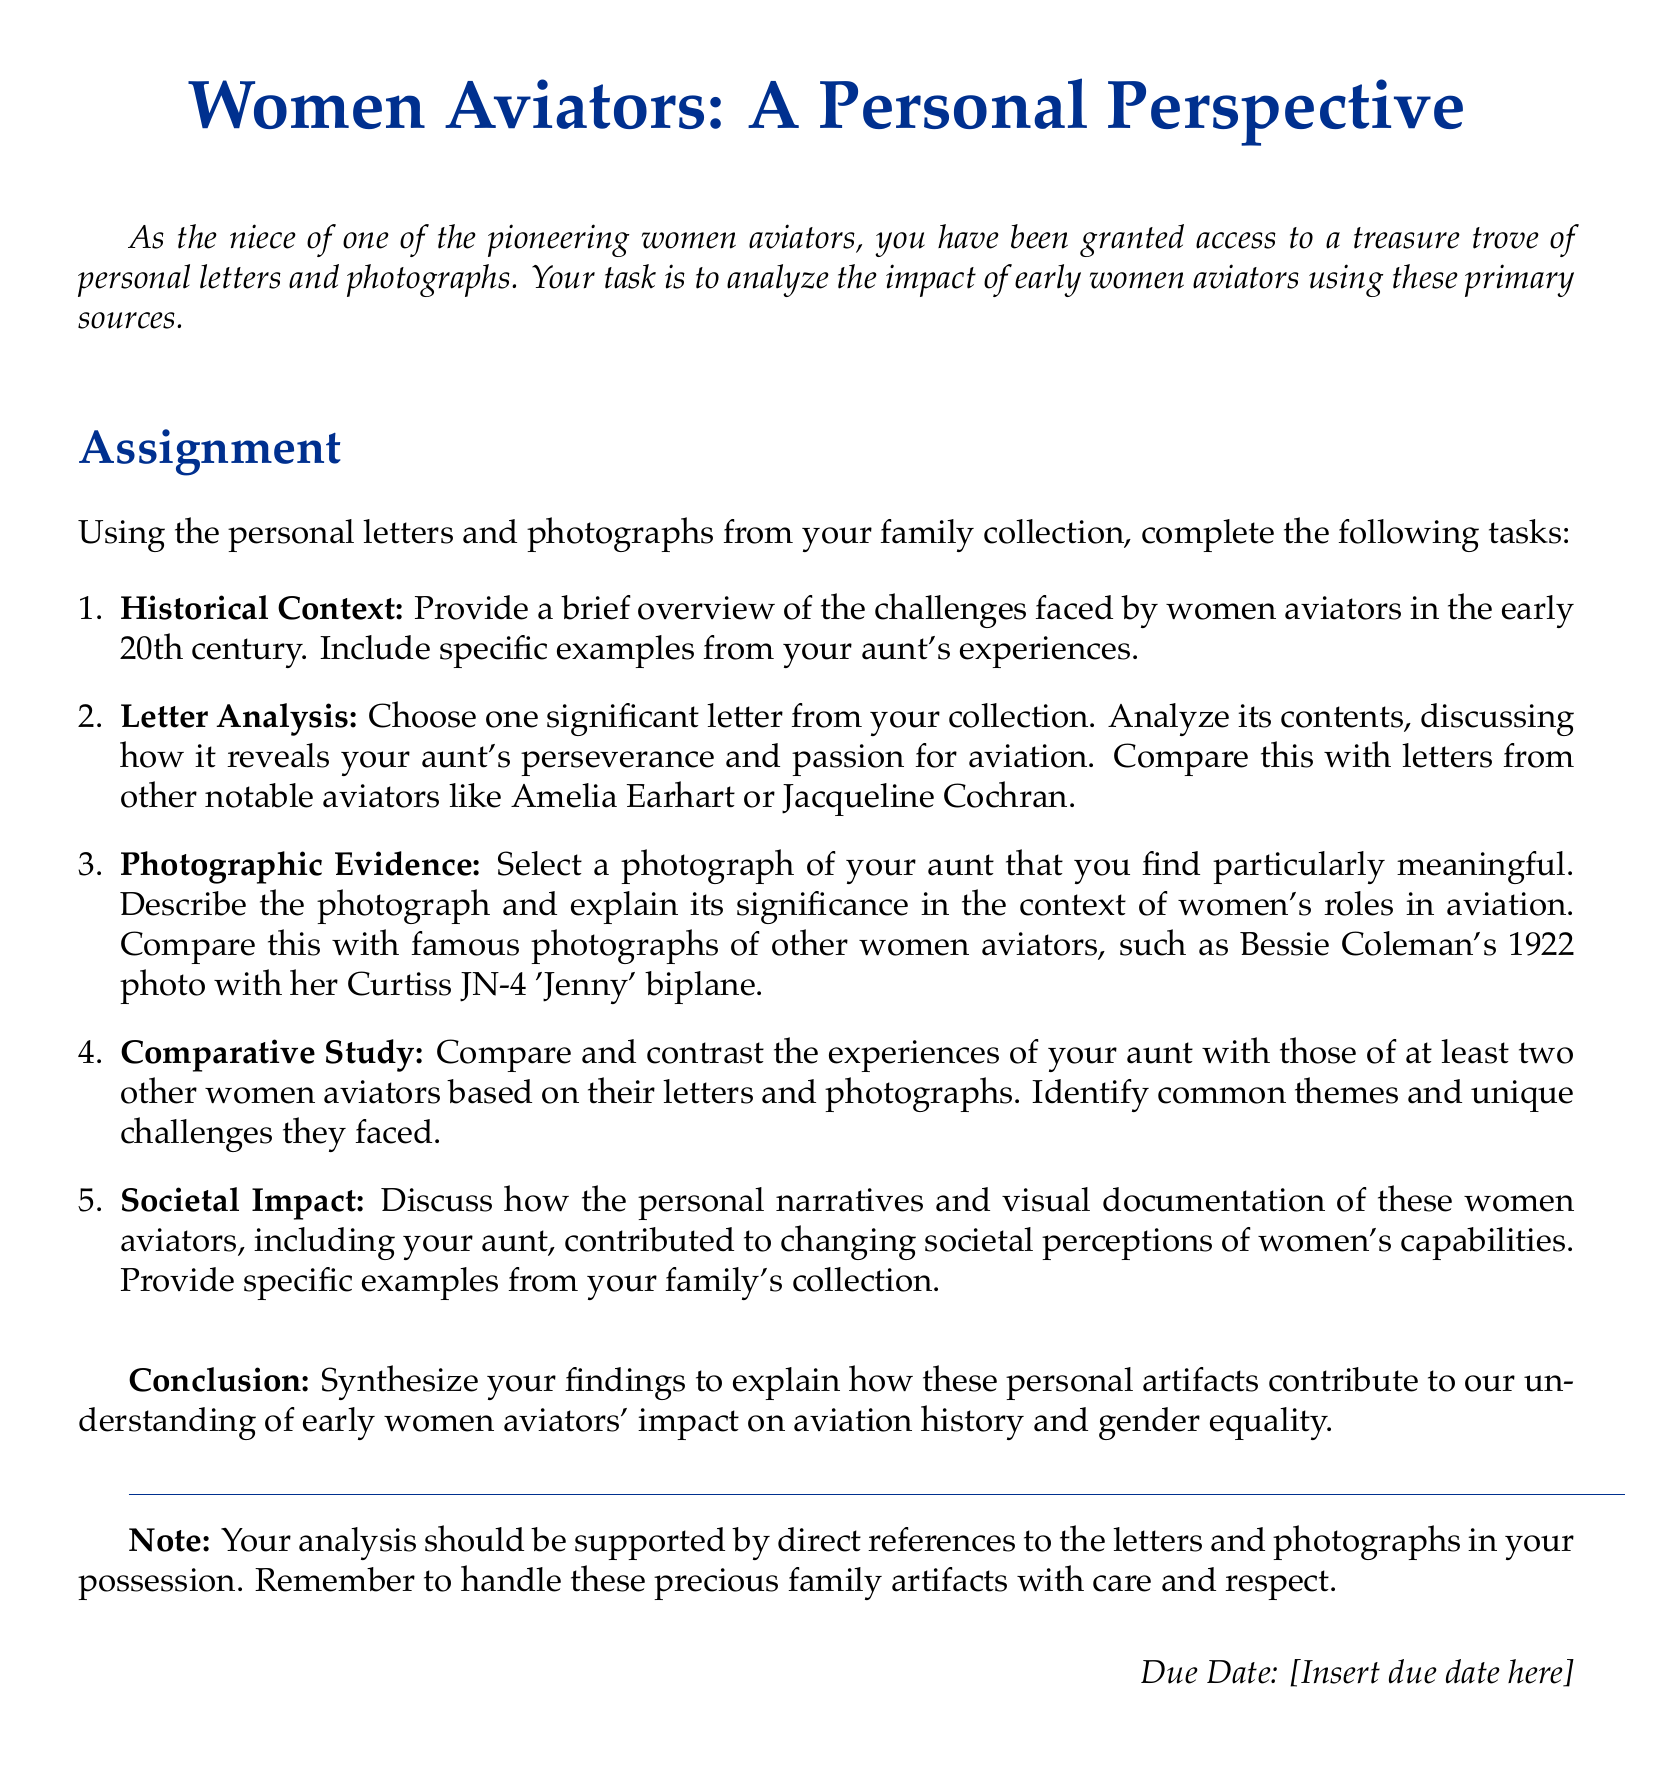What is the title of the document? The title of the document is presented prominently at the top of the rendered document.
Answer: Women Aviators: A Personal Perspective What is the primary task of the assignment? The document outlines the main focus of the assignment in the introduction.
Answer: Analyze the impact of early women aviators Who is mentioned as one notable aviator to compare with? The document specifies key figures from the history of women aviators to use for analysis.
Answer: Amelia Earhart What color is used for the document's title? The color of the title is described in the formatting section.
Answer: aviatorblue What type of sources will be analyzed according to the assignment? The assignment explicitly states the types of sources to be analyzed.
Answer: Personal letters and photographs What is the deadline instruction in the document? The document concludes with information regarding submission timelines and is noted at the bottom.
Answer: Insert due date here How many specific tasks are listed in the assignment? The total number of tasks is clearly outlined in the enumeration section.
Answer: Five What themes are requested for comparison in the assignment? The document prompts the need to identify key themes amidst the experiences of different aviators.
Answer: Common themes and unique challenges What is emphasized regarding the handling of family artifacts? The document advises careful treatment of sensitive family items.
Answer: Handle these precious family artifacts with care and respect 